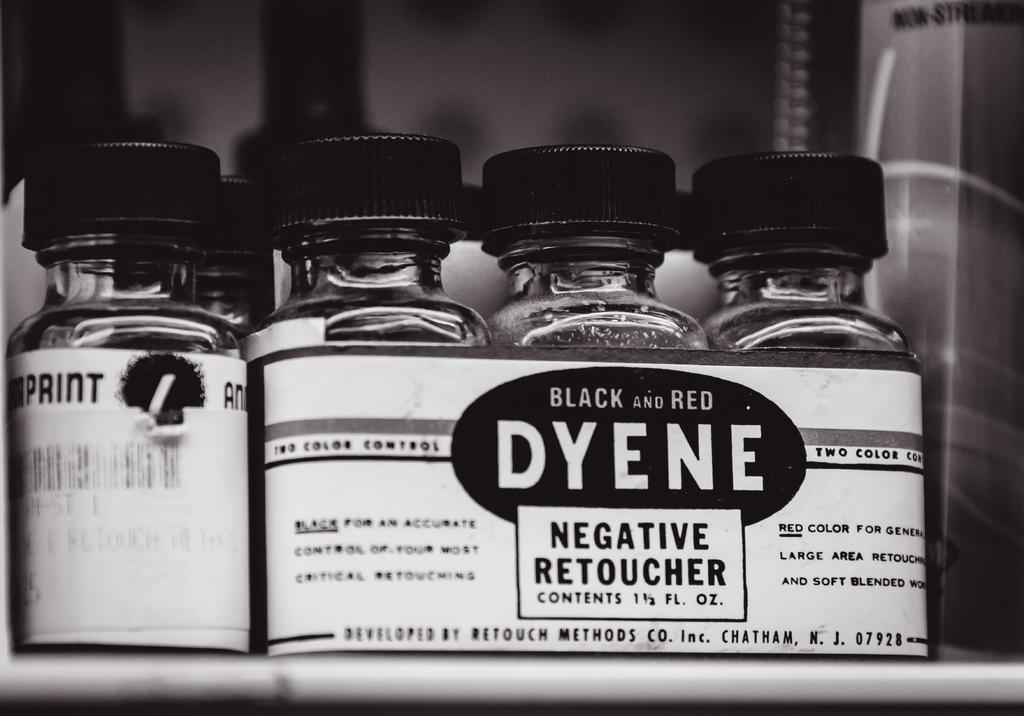Provide a one-sentence caption for the provided image. Bottles of Negative Retoucher with the name Dyene on the front. 